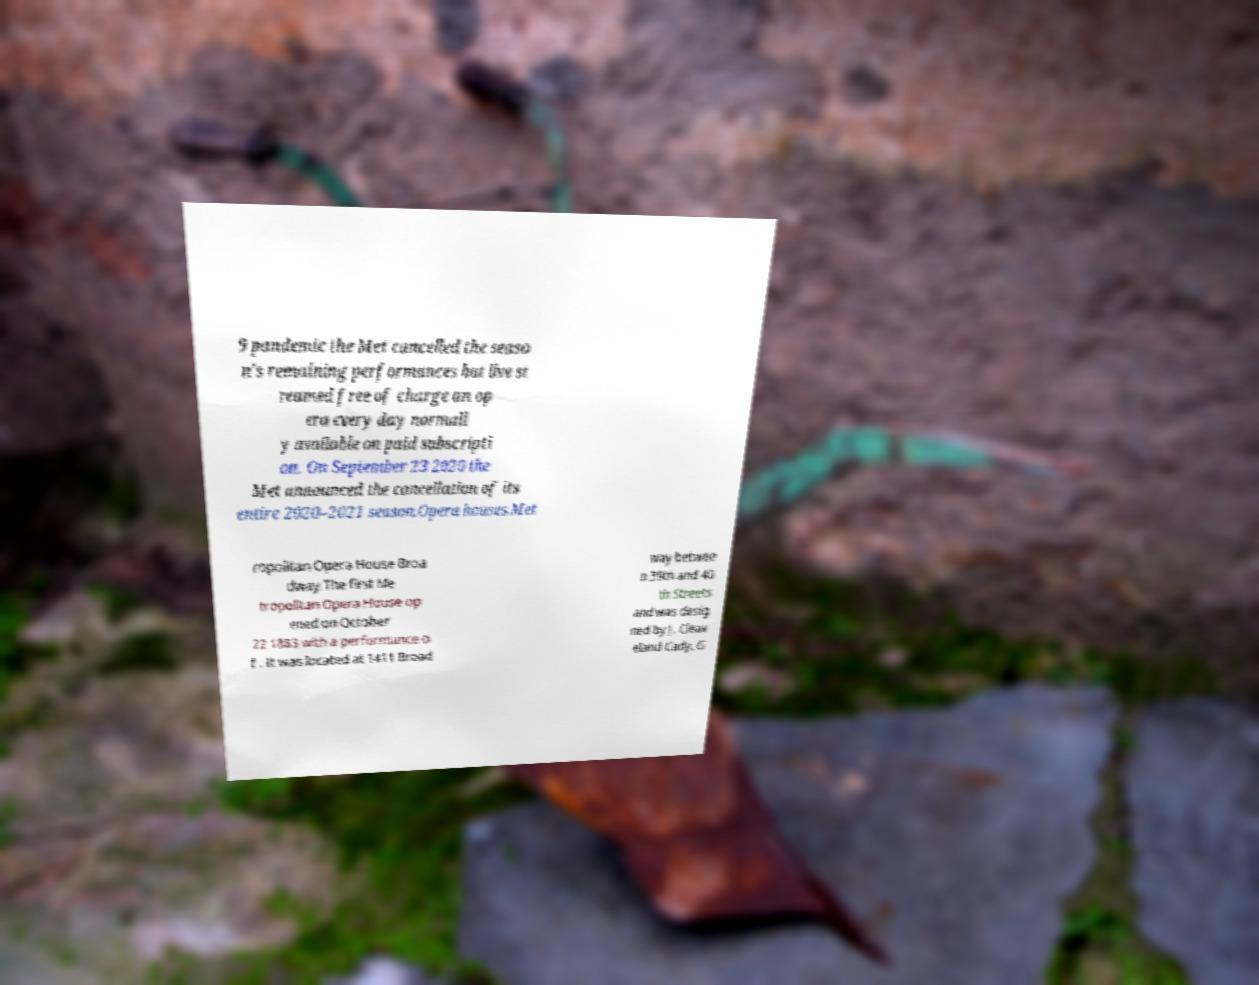Can you accurately transcribe the text from the provided image for me? 9 pandemic the Met cancelled the seaso n's remaining performances but live st reamed free of charge an op era every day normall y available on paid subscripti on. On September 23 2020 the Met announced the cancellation of its entire 2020–2021 season.Opera houses.Met ropolitan Opera House Broa dway.The first Me tropolitan Opera House op ened on October 22 1883 with a performance o f . It was located at 1411 Broad way betwee n 39th and 40 th Streets and was desig ned by J. Cleav eland Cady. G 